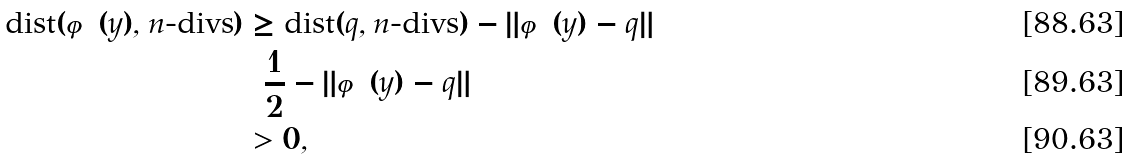<formula> <loc_0><loc_0><loc_500><loc_500>\text {dist} ( \varphi ( y ) , n \text {-divs} ) & \geq \text {dist} ( q , n \text {-divs} ) - \| \varphi ( y ) - q \| \\ & = \frac { 1 } { 2 } - \| \varphi ( y ) - q \| \\ & > 0 ,</formula> 